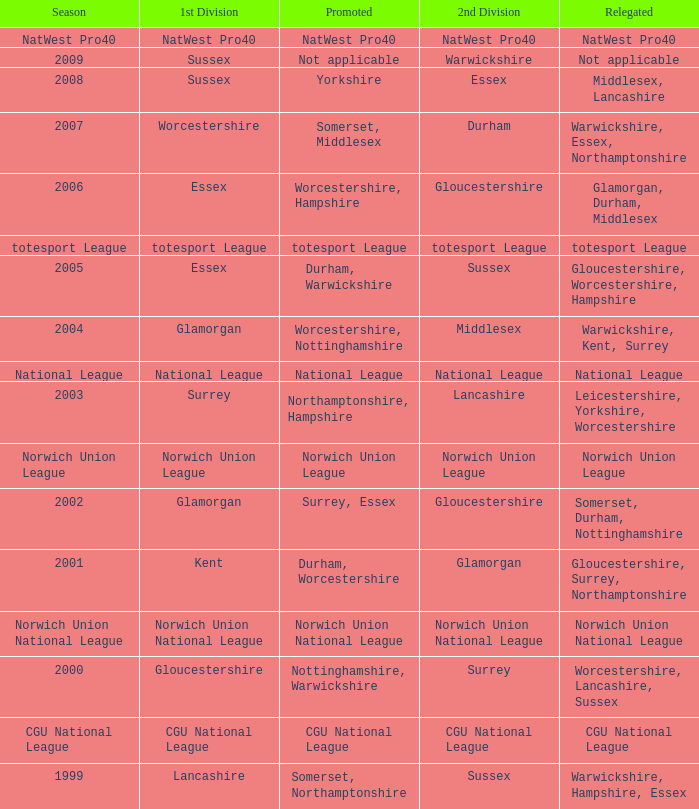What season was Norwich Union League promoted? Norwich Union League. 